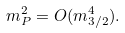<formula> <loc_0><loc_0><loc_500><loc_500>m _ { P } ^ { 2 } = O ( m _ { 3 / 2 } ^ { 4 } ) .</formula> 